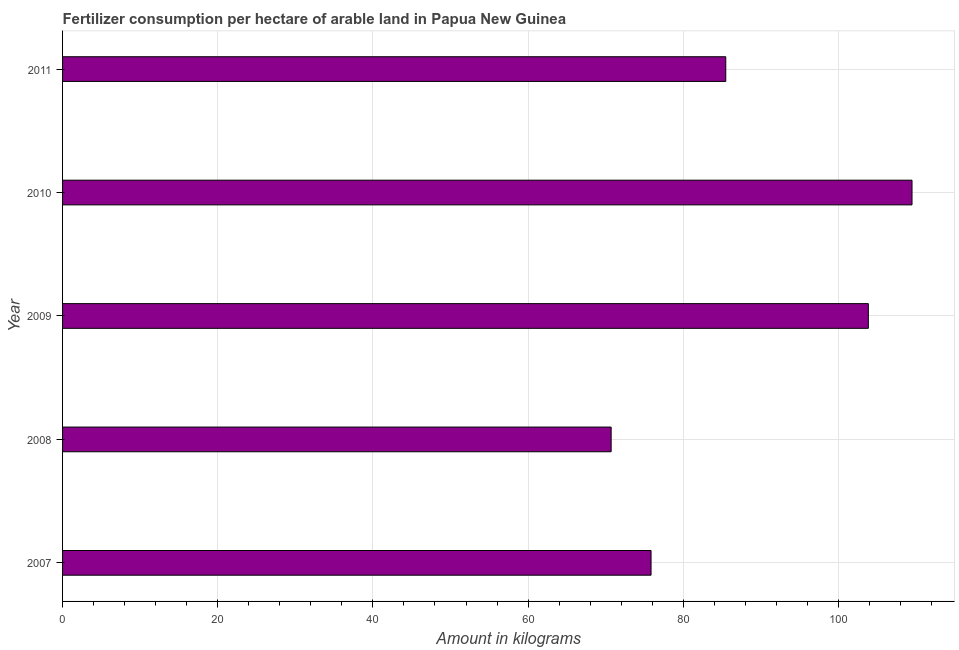Does the graph contain grids?
Your answer should be very brief. Yes. What is the title of the graph?
Your answer should be very brief. Fertilizer consumption per hectare of arable land in Papua New Guinea . What is the label or title of the X-axis?
Provide a succinct answer. Amount in kilograms. What is the label or title of the Y-axis?
Your answer should be compact. Year. What is the amount of fertilizer consumption in 2010?
Offer a very short reply. 109.48. Across all years, what is the maximum amount of fertilizer consumption?
Make the answer very short. 109.48. Across all years, what is the minimum amount of fertilizer consumption?
Provide a succinct answer. 70.7. In which year was the amount of fertilizer consumption maximum?
Offer a very short reply. 2010. In which year was the amount of fertilizer consumption minimum?
Your response must be concise. 2008. What is the sum of the amount of fertilizer consumption?
Give a very brief answer. 445.36. What is the difference between the amount of fertilizer consumption in 2009 and 2010?
Ensure brevity in your answer.  -5.63. What is the average amount of fertilizer consumption per year?
Provide a short and direct response. 89.07. What is the median amount of fertilizer consumption?
Keep it short and to the point. 85.48. In how many years, is the amount of fertilizer consumption greater than 8 kg?
Your answer should be compact. 5. Do a majority of the years between 2009 and 2010 (inclusive) have amount of fertilizer consumption greater than 88 kg?
Give a very brief answer. Yes. What is the ratio of the amount of fertilizer consumption in 2010 to that in 2011?
Provide a short and direct response. 1.28. Is the amount of fertilizer consumption in 2008 less than that in 2010?
Your answer should be very brief. Yes. What is the difference between the highest and the second highest amount of fertilizer consumption?
Provide a succinct answer. 5.63. Is the sum of the amount of fertilizer consumption in 2007 and 2009 greater than the maximum amount of fertilizer consumption across all years?
Offer a very short reply. Yes. What is the difference between the highest and the lowest amount of fertilizer consumption?
Provide a succinct answer. 38.78. Are all the bars in the graph horizontal?
Make the answer very short. Yes. How many years are there in the graph?
Make the answer very short. 5. What is the difference between two consecutive major ticks on the X-axis?
Your answer should be very brief. 20. What is the Amount in kilograms in 2007?
Ensure brevity in your answer.  75.85. What is the Amount in kilograms of 2008?
Give a very brief answer. 70.7. What is the Amount in kilograms in 2009?
Your answer should be compact. 103.85. What is the Amount in kilograms of 2010?
Your answer should be compact. 109.48. What is the Amount in kilograms of 2011?
Offer a terse response. 85.48. What is the difference between the Amount in kilograms in 2007 and 2008?
Provide a succinct answer. 5.14. What is the difference between the Amount in kilograms in 2007 and 2009?
Your response must be concise. -28.01. What is the difference between the Amount in kilograms in 2007 and 2010?
Provide a succinct answer. -33.64. What is the difference between the Amount in kilograms in 2007 and 2011?
Provide a succinct answer. -9.63. What is the difference between the Amount in kilograms in 2008 and 2009?
Keep it short and to the point. -33.15. What is the difference between the Amount in kilograms in 2008 and 2010?
Your response must be concise. -38.78. What is the difference between the Amount in kilograms in 2008 and 2011?
Make the answer very short. -14.77. What is the difference between the Amount in kilograms in 2009 and 2010?
Make the answer very short. -5.63. What is the difference between the Amount in kilograms in 2009 and 2011?
Your response must be concise. 18.38. What is the difference between the Amount in kilograms in 2010 and 2011?
Make the answer very short. 24.01. What is the ratio of the Amount in kilograms in 2007 to that in 2008?
Keep it short and to the point. 1.07. What is the ratio of the Amount in kilograms in 2007 to that in 2009?
Your answer should be compact. 0.73. What is the ratio of the Amount in kilograms in 2007 to that in 2010?
Your answer should be very brief. 0.69. What is the ratio of the Amount in kilograms in 2007 to that in 2011?
Ensure brevity in your answer.  0.89. What is the ratio of the Amount in kilograms in 2008 to that in 2009?
Offer a terse response. 0.68. What is the ratio of the Amount in kilograms in 2008 to that in 2010?
Ensure brevity in your answer.  0.65. What is the ratio of the Amount in kilograms in 2008 to that in 2011?
Make the answer very short. 0.83. What is the ratio of the Amount in kilograms in 2009 to that in 2010?
Provide a short and direct response. 0.95. What is the ratio of the Amount in kilograms in 2009 to that in 2011?
Give a very brief answer. 1.22. What is the ratio of the Amount in kilograms in 2010 to that in 2011?
Offer a terse response. 1.28. 